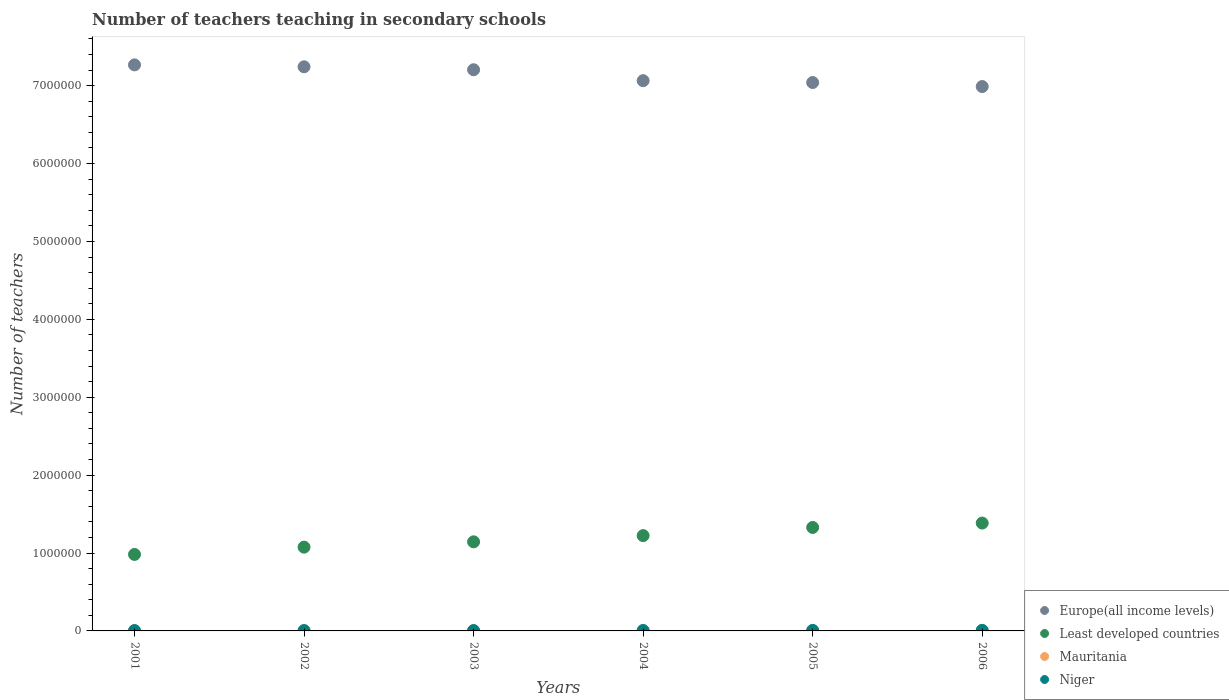Is the number of dotlines equal to the number of legend labels?
Your response must be concise. Yes. What is the number of teachers teaching in secondary schools in Least developed countries in 2001?
Give a very brief answer. 9.82e+05. Across all years, what is the maximum number of teachers teaching in secondary schools in Least developed countries?
Your answer should be compact. 1.38e+06. Across all years, what is the minimum number of teachers teaching in secondary schools in Europe(all income levels)?
Your response must be concise. 6.99e+06. In which year was the number of teachers teaching in secondary schools in Least developed countries minimum?
Offer a very short reply. 2001. What is the total number of teachers teaching in secondary schools in Least developed countries in the graph?
Provide a short and direct response. 7.14e+06. What is the difference between the number of teachers teaching in secondary schools in Niger in 2001 and that in 2006?
Provide a succinct answer. -2769. What is the difference between the number of teachers teaching in secondary schools in Least developed countries in 2006 and the number of teachers teaching in secondary schools in Niger in 2001?
Offer a very short reply. 1.38e+06. What is the average number of teachers teaching in secondary schools in Europe(all income levels) per year?
Your response must be concise. 7.13e+06. In the year 2004, what is the difference between the number of teachers teaching in secondary schools in Europe(all income levels) and number of teachers teaching in secondary schools in Niger?
Make the answer very short. 7.06e+06. What is the ratio of the number of teachers teaching in secondary schools in Least developed countries in 2003 to that in 2004?
Offer a very short reply. 0.93. Is the number of teachers teaching in secondary schools in Niger in 2003 less than that in 2005?
Your response must be concise. Yes. Is the difference between the number of teachers teaching in secondary schools in Europe(all income levels) in 2004 and 2005 greater than the difference between the number of teachers teaching in secondary schools in Niger in 2004 and 2005?
Keep it short and to the point. Yes. What is the difference between the highest and the second highest number of teachers teaching in secondary schools in Niger?
Your answer should be very brief. 725. What is the difference between the highest and the lowest number of teachers teaching in secondary schools in Least developed countries?
Provide a short and direct response. 4.03e+05. Is it the case that in every year, the sum of the number of teachers teaching in secondary schools in Niger and number of teachers teaching in secondary schools in Mauritania  is greater than the sum of number of teachers teaching in secondary schools in Europe(all income levels) and number of teachers teaching in secondary schools in Least developed countries?
Ensure brevity in your answer.  No. Is the number of teachers teaching in secondary schools in Niger strictly greater than the number of teachers teaching in secondary schools in Least developed countries over the years?
Your answer should be compact. No. Is the number of teachers teaching in secondary schools in Europe(all income levels) strictly less than the number of teachers teaching in secondary schools in Mauritania over the years?
Keep it short and to the point. No. How many years are there in the graph?
Your answer should be compact. 6. Are the values on the major ticks of Y-axis written in scientific E-notation?
Keep it short and to the point. No. Does the graph contain grids?
Your answer should be compact. No. Where does the legend appear in the graph?
Keep it short and to the point. Bottom right. How many legend labels are there?
Your answer should be compact. 4. What is the title of the graph?
Offer a very short reply. Number of teachers teaching in secondary schools. Does "West Bank and Gaza" appear as one of the legend labels in the graph?
Your answer should be very brief. No. What is the label or title of the X-axis?
Give a very brief answer. Years. What is the label or title of the Y-axis?
Offer a terse response. Number of teachers. What is the Number of teachers in Europe(all income levels) in 2001?
Keep it short and to the point. 7.27e+06. What is the Number of teachers of Least developed countries in 2001?
Offer a very short reply. 9.82e+05. What is the Number of teachers in Mauritania in 2001?
Ensure brevity in your answer.  2911. What is the Number of teachers of Niger in 2001?
Ensure brevity in your answer.  4589. What is the Number of teachers of Europe(all income levels) in 2002?
Give a very brief answer. 7.24e+06. What is the Number of teachers in Least developed countries in 2002?
Provide a succinct answer. 1.08e+06. What is the Number of teachers in Mauritania in 2002?
Provide a short and direct response. 3000. What is the Number of teachers in Niger in 2002?
Ensure brevity in your answer.  4165. What is the Number of teachers of Europe(all income levels) in 2003?
Keep it short and to the point. 7.20e+06. What is the Number of teachers in Least developed countries in 2003?
Make the answer very short. 1.14e+06. What is the Number of teachers in Mauritania in 2003?
Your answer should be very brief. 3237. What is the Number of teachers of Niger in 2003?
Provide a succinct answer. 4406. What is the Number of teachers of Europe(all income levels) in 2004?
Provide a short and direct response. 7.06e+06. What is the Number of teachers in Least developed countries in 2004?
Your answer should be very brief. 1.22e+06. What is the Number of teachers of Mauritania in 2004?
Your answer should be compact. 3126. What is the Number of teachers in Niger in 2004?
Your response must be concise. 5131. What is the Number of teachers of Europe(all income levels) in 2005?
Your response must be concise. 7.04e+06. What is the Number of teachers of Least developed countries in 2005?
Offer a very short reply. 1.33e+06. What is the Number of teachers of Mauritania in 2005?
Your answer should be compact. 2995. What is the Number of teachers of Niger in 2005?
Keep it short and to the point. 6633. What is the Number of teachers of Europe(all income levels) in 2006?
Provide a short and direct response. 6.99e+06. What is the Number of teachers of Least developed countries in 2006?
Your answer should be compact. 1.38e+06. What is the Number of teachers of Mauritania in 2006?
Your answer should be compact. 3777. What is the Number of teachers in Niger in 2006?
Keep it short and to the point. 7358. Across all years, what is the maximum Number of teachers in Europe(all income levels)?
Your answer should be very brief. 7.27e+06. Across all years, what is the maximum Number of teachers in Least developed countries?
Make the answer very short. 1.38e+06. Across all years, what is the maximum Number of teachers of Mauritania?
Your answer should be very brief. 3777. Across all years, what is the maximum Number of teachers of Niger?
Give a very brief answer. 7358. Across all years, what is the minimum Number of teachers in Europe(all income levels)?
Your answer should be compact. 6.99e+06. Across all years, what is the minimum Number of teachers of Least developed countries?
Give a very brief answer. 9.82e+05. Across all years, what is the minimum Number of teachers of Mauritania?
Offer a terse response. 2911. Across all years, what is the minimum Number of teachers of Niger?
Keep it short and to the point. 4165. What is the total Number of teachers of Europe(all income levels) in the graph?
Provide a succinct answer. 4.28e+07. What is the total Number of teachers in Least developed countries in the graph?
Your answer should be compact. 7.14e+06. What is the total Number of teachers of Mauritania in the graph?
Offer a very short reply. 1.90e+04. What is the total Number of teachers of Niger in the graph?
Give a very brief answer. 3.23e+04. What is the difference between the Number of teachers in Europe(all income levels) in 2001 and that in 2002?
Keep it short and to the point. 2.47e+04. What is the difference between the Number of teachers in Least developed countries in 2001 and that in 2002?
Give a very brief answer. -9.37e+04. What is the difference between the Number of teachers of Mauritania in 2001 and that in 2002?
Give a very brief answer. -89. What is the difference between the Number of teachers of Niger in 2001 and that in 2002?
Offer a terse response. 424. What is the difference between the Number of teachers in Europe(all income levels) in 2001 and that in 2003?
Offer a terse response. 6.26e+04. What is the difference between the Number of teachers of Least developed countries in 2001 and that in 2003?
Keep it short and to the point. -1.62e+05. What is the difference between the Number of teachers in Mauritania in 2001 and that in 2003?
Offer a very short reply. -326. What is the difference between the Number of teachers in Niger in 2001 and that in 2003?
Make the answer very short. 183. What is the difference between the Number of teachers in Europe(all income levels) in 2001 and that in 2004?
Provide a short and direct response. 2.03e+05. What is the difference between the Number of teachers in Least developed countries in 2001 and that in 2004?
Provide a short and direct response. -2.42e+05. What is the difference between the Number of teachers in Mauritania in 2001 and that in 2004?
Provide a short and direct response. -215. What is the difference between the Number of teachers of Niger in 2001 and that in 2004?
Your response must be concise. -542. What is the difference between the Number of teachers in Europe(all income levels) in 2001 and that in 2005?
Provide a succinct answer. 2.27e+05. What is the difference between the Number of teachers of Least developed countries in 2001 and that in 2005?
Provide a short and direct response. -3.47e+05. What is the difference between the Number of teachers in Mauritania in 2001 and that in 2005?
Make the answer very short. -84. What is the difference between the Number of teachers in Niger in 2001 and that in 2005?
Provide a succinct answer. -2044. What is the difference between the Number of teachers in Europe(all income levels) in 2001 and that in 2006?
Your answer should be very brief. 2.78e+05. What is the difference between the Number of teachers in Least developed countries in 2001 and that in 2006?
Keep it short and to the point. -4.03e+05. What is the difference between the Number of teachers of Mauritania in 2001 and that in 2006?
Keep it short and to the point. -866. What is the difference between the Number of teachers of Niger in 2001 and that in 2006?
Provide a succinct answer. -2769. What is the difference between the Number of teachers in Europe(all income levels) in 2002 and that in 2003?
Provide a short and direct response. 3.80e+04. What is the difference between the Number of teachers in Least developed countries in 2002 and that in 2003?
Provide a short and direct response. -6.84e+04. What is the difference between the Number of teachers of Mauritania in 2002 and that in 2003?
Make the answer very short. -237. What is the difference between the Number of teachers of Niger in 2002 and that in 2003?
Give a very brief answer. -241. What is the difference between the Number of teachers in Europe(all income levels) in 2002 and that in 2004?
Make the answer very short. 1.78e+05. What is the difference between the Number of teachers in Least developed countries in 2002 and that in 2004?
Keep it short and to the point. -1.48e+05. What is the difference between the Number of teachers of Mauritania in 2002 and that in 2004?
Your answer should be compact. -126. What is the difference between the Number of teachers in Niger in 2002 and that in 2004?
Offer a very short reply. -966. What is the difference between the Number of teachers in Europe(all income levels) in 2002 and that in 2005?
Offer a terse response. 2.02e+05. What is the difference between the Number of teachers of Least developed countries in 2002 and that in 2005?
Your response must be concise. -2.53e+05. What is the difference between the Number of teachers in Mauritania in 2002 and that in 2005?
Offer a very short reply. 5. What is the difference between the Number of teachers of Niger in 2002 and that in 2005?
Your answer should be compact. -2468. What is the difference between the Number of teachers in Europe(all income levels) in 2002 and that in 2006?
Offer a terse response. 2.54e+05. What is the difference between the Number of teachers of Least developed countries in 2002 and that in 2006?
Your answer should be compact. -3.09e+05. What is the difference between the Number of teachers in Mauritania in 2002 and that in 2006?
Your answer should be very brief. -777. What is the difference between the Number of teachers in Niger in 2002 and that in 2006?
Your answer should be compact. -3193. What is the difference between the Number of teachers in Europe(all income levels) in 2003 and that in 2004?
Your answer should be compact. 1.40e+05. What is the difference between the Number of teachers of Least developed countries in 2003 and that in 2004?
Your answer should be compact. -7.97e+04. What is the difference between the Number of teachers of Mauritania in 2003 and that in 2004?
Provide a succinct answer. 111. What is the difference between the Number of teachers in Niger in 2003 and that in 2004?
Make the answer very short. -725. What is the difference between the Number of teachers of Europe(all income levels) in 2003 and that in 2005?
Make the answer very short. 1.64e+05. What is the difference between the Number of teachers of Least developed countries in 2003 and that in 2005?
Provide a short and direct response. -1.85e+05. What is the difference between the Number of teachers of Mauritania in 2003 and that in 2005?
Your response must be concise. 242. What is the difference between the Number of teachers in Niger in 2003 and that in 2005?
Your response must be concise. -2227. What is the difference between the Number of teachers of Europe(all income levels) in 2003 and that in 2006?
Ensure brevity in your answer.  2.16e+05. What is the difference between the Number of teachers of Least developed countries in 2003 and that in 2006?
Your answer should be compact. -2.41e+05. What is the difference between the Number of teachers of Mauritania in 2003 and that in 2006?
Offer a very short reply. -540. What is the difference between the Number of teachers in Niger in 2003 and that in 2006?
Offer a terse response. -2952. What is the difference between the Number of teachers in Europe(all income levels) in 2004 and that in 2005?
Provide a succinct answer. 2.37e+04. What is the difference between the Number of teachers of Least developed countries in 2004 and that in 2005?
Offer a terse response. -1.05e+05. What is the difference between the Number of teachers in Mauritania in 2004 and that in 2005?
Offer a terse response. 131. What is the difference between the Number of teachers of Niger in 2004 and that in 2005?
Make the answer very short. -1502. What is the difference between the Number of teachers in Europe(all income levels) in 2004 and that in 2006?
Your answer should be very brief. 7.53e+04. What is the difference between the Number of teachers in Least developed countries in 2004 and that in 2006?
Provide a succinct answer. -1.61e+05. What is the difference between the Number of teachers of Mauritania in 2004 and that in 2006?
Give a very brief answer. -651. What is the difference between the Number of teachers of Niger in 2004 and that in 2006?
Ensure brevity in your answer.  -2227. What is the difference between the Number of teachers in Europe(all income levels) in 2005 and that in 2006?
Give a very brief answer. 5.16e+04. What is the difference between the Number of teachers of Least developed countries in 2005 and that in 2006?
Give a very brief answer. -5.61e+04. What is the difference between the Number of teachers in Mauritania in 2005 and that in 2006?
Your response must be concise. -782. What is the difference between the Number of teachers in Niger in 2005 and that in 2006?
Offer a very short reply. -725. What is the difference between the Number of teachers in Europe(all income levels) in 2001 and the Number of teachers in Least developed countries in 2002?
Ensure brevity in your answer.  6.19e+06. What is the difference between the Number of teachers of Europe(all income levels) in 2001 and the Number of teachers of Mauritania in 2002?
Give a very brief answer. 7.26e+06. What is the difference between the Number of teachers of Europe(all income levels) in 2001 and the Number of teachers of Niger in 2002?
Your answer should be very brief. 7.26e+06. What is the difference between the Number of teachers of Least developed countries in 2001 and the Number of teachers of Mauritania in 2002?
Your answer should be very brief. 9.79e+05. What is the difference between the Number of teachers in Least developed countries in 2001 and the Number of teachers in Niger in 2002?
Give a very brief answer. 9.78e+05. What is the difference between the Number of teachers in Mauritania in 2001 and the Number of teachers in Niger in 2002?
Make the answer very short. -1254. What is the difference between the Number of teachers in Europe(all income levels) in 2001 and the Number of teachers in Least developed countries in 2003?
Your answer should be compact. 6.12e+06. What is the difference between the Number of teachers in Europe(all income levels) in 2001 and the Number of teachers in Mauritania in 2003?
Ensure brevity in your answer.  7.26e+06. What is the difference between the Number of teachers of Europe(all income levels) in 2001 and the Number of teachers of Niger in 2003?
Provide a succinct answer. 7.26e+06. What is the difference between the Number of teachers in Least developed countries in 2001 and the Number of teachers in Mauritania in 2003?
Your answer should be very brief. 9.79e+05. What is the difference between the Number of teachers in Least developed countries in 2001 and the Number of teachers in Niger in 2003?
Offer a terse response. 9.77e+05. What is the difference between the Number of teachers in Mauritania in 2001 and the Number of teachers in Niger in 2003?
Offer a terse response. -1495. What is the difference between the Number of teachers in Europe(all income levels) in 2001 and the Number of teachers in Least developed countries in 2004?
Your answer should be very brief. 6.04e+06. What is the difference between the Number of teachers in Europe(all income levels) in 2001 and the Number of teachers in Mauritania in 2004?
Provide a succinct answer. 7.26e+06. What is the difference between the Number of teachers of Europe(all income levels) in 2001 and the Number of teachers of Niger in 2004?
Your answer should be compact. 7.26e+06. What is the difference between the Number of teachers in Least developed countries in 2001 and the Number of teachers in Mauritania in 2004?
Your response must be concise. 9.79e+05. What is the difference between the Number of teachers of Least developed countries in 2001 and the Number of teachers of Niger in 2004?
Give a very brief answer. 9.77e+05. What is the difference between the Number of teachers in Mauritania in 2001 and the Number of teachers in Niger in 2004?
Provide a succinct answer. -2220. What is the difference between the Number of teachers in Europe(all income levels) in 2001 and the Number of teachers in Least developed countries in 2005?
Provide a succinct answer. 5.94e+06. What is the difference between the Number of teachers of Europe(all income levels) in 2001 and the Number of teachers of Mauritania in 2005?
Make the answer very short. 7.26e+06. What is the difference between the Number of teachers of Europe(all income levels) in 2001 and the Number of teachers of Niger in 2005?
Your answer should be very brief. 7.26e+06. What is the difference between the Number of teachers in Least developed countries in 2001 and the Number of teachers in Mauritania in 2005?
Provide a short and direct response. 9.79e+05. What is the difference between the Number of teachers in Least developed countries in 2001 and the Number of teachers in Niger in 2005?
Make the answer very short. 9.75e+05. What is the difference between the Number of teachers of Mauritania in 2001 and the Number of teachers of Niger in 2005?
Provide a succinct answer. -3722. What is the difference between the Number of teachers in Europe(all income levels) in 2001 and the Number of teachers in Least developed countries in 2006?
Your answer should be very brief. 5.88e+06. What is the difference between the Number of teachers of Europe(all income levels) in 2001 and the Number of teachers of Mauritania in 2006?
Keep it short and to the point. 7.26e+06. What is the difference between the Number of teachers in Europe(all income levels) in 2001 and the Number of teachers in Niger in 2006?
Ensure brevity in your answer.  7.26e+06. What is the difference between the Number of teachers in Least developed countries in 2001 and the Number of teachers in Mauritania in 2006?
Your response must be concise. 9.78e+05. What is the difference between the Number of teachers in Least developed countries in 2001 and the Number of teachers in Niger in 2006?
Your answer should be very brief. 9.74e+05. What is the difference between the Number of teachers in Mauritania in 2001 and the Number of teachers in Niger in 2006?
Your response must be concise. -4447. What is the difference between the Number of teachers of Europe(all income levels) in 2002 and the Number of teachers of Least developed countries in 2003?
Offer a terse response. 6.10e+06. What is the difference between the Number of teachers in Europe(all income levels) in 2002 and the Number of teachers in Mauritania in 2003?
Keep it short and to the point. 7.24e+06. What is the difference between the Number of teachers of Europe(all income levels) in 2002 and the Number of teachers of Niger in 2003?
Ensure brevity in your answer.  7.24e+06. What is the difference between the Number of teachers of Least developed countries in 2002 and the Number of teachers of Mauritania in 2003?
Your answer should be very brief. 1.07e+06. What is the difference between the Number of teachers of Least developed countries in 2002 and the Number of teachers of Niger in 2003?
Give a very brief answer. 1.07e+06. What is the difference between the Number of teachers of Mauritania in 2002 and the Number of teachers of Niger in 2003?
Make the answer very short. -1406. What is the difference between the Number of teachers in Europe(all income levels) in 2002 and the Number of teachers in Least developed countries in 2004?
Offer a very short reply. 6.02e+06. What is the difference between the Number of teachers in Europe(all income levels) in 2002 and the Number of teachers in Mauritania in 2004?
Your answer should be very brief. 7.24e+06. What is the difference between the Number of teachers of Europe(all income levels) in 2002 and the Number of teachers of Niger in 2004?
Make the answer very short. 7.24e+06. What is the difference between the Number of teachers of Least developed countries in 2002 and the Number of teachers of Mauritania in 2004?
Make the answer very short. 1.07e+06. What is the difference between the Number of teachers of Least developed countries in 2002 and the Number of teachers of Niger in 2004?
Your answer should be compact. 1.07e+06. What is the difference between the Number of teachers in Mauritania in 2002 and the Number of teachers in Niger in 2004?
Your response must be concise. -2131. What is the difference between the Number of teachers in Europe(all income levels) in 2002 and the Number of teachers in Least developed countries in 2005?
Your answer should be very brief. 5.91e+06. What is the difference between the Number of teachers of Europe(all income levels) in 2002 and the Number of teachers of Mauritania in 2005?
Offer a very short reply. 7.24e+06. What is the difference between the Number of teachers in Europe(all income levels) in 2002 and the Number of teachers in Niger in 2005?
Provide a succinct answer. 7.24e+06. What is the difference between the Number of teachers in Least developed countries in 2002 and the Number of teachers in Mauritania in 2005?
Your answer should be very brief. 1.07e+06. What is the difference between the Number of teachers of Least developed countries in 2002 and the Number of teachers of Niger in 2005?
Your answer should be very brief. 1.07e+06. What is the difference between the Number of teachers of Mauritania in 2002 and the Number of teachers of Niger in 2005?
Give a very brief answer. -3633. What is the difference between the Number of teachers in Europe(all income levels) in 2002 and the Number of teachers in Least developed countries in 2006?
Ensure brevity in your answer.  5.86e+06. What is the difference between the Number of teachers of Europe(all income levels) in 2002 and the Number of teachers of Mauritania in 2006?
Give a very brief answer. 7.24e+06. What is the difference between the Number of teachers in Europe(all income levels) in 2002 and the Number of teachers in Niger in 2006?
Your response must be concise. 7.24e+06. What is the difference between the Number of teachers in Least developed countries in 2002 and the Number of teachers in Mauritania in 2006?
Ensure brevity in your answer.  1.07e+06. What is the difference between the Number of teachers in Least developed countries in 2002 and the Number of teachers in Niger in 2006?
Offer a very short reply. 1.07e+06. What is the difference between the Number of teachers of Mauritania in 2002 and the Number of teachers of Niger in 2006?
Your answer should be very brief. -4358. What is the difference between the Number of teachers in Europe(all income levels) in 2003 and the Number of teachers in Least developed countries in 2004?
Offer a very short reply. 5.98e+06. What is the difference between the Number of teachers of Europe(all income levels) in 2003 and the Number of teachers of Mauritania in 2004?
Provide a succinct answer. 7.20e+06. What is the difference between the Number of teachers in Europe(all income levels) in 2003 and the Number of teachers in Niger in 2004?
Ensure brevity in your answer.  7.20e+06. What is the difference between the Number of teachers in Least developed countries in 2003 and the Number of teachers in Mauritania in 2004?
Provide a short and direct response. 1.14e+06. What is the difference between the Number of teachers of Least developed countries in 2003 and the Number of teachers of Niger in 2004?
Keep it short and to the point. 1.14e+06. What is the difference between the Number of teachers of Mauritania in 2003 and the Number of teachers of Niger in 2004?
Keep it short and to the point. -1894. What is the difference between the Number of teachers in Europe(all income levels) in 2003 and the Number of teachers in Least developed countries in 2005?
Your response must be concise. 5.88e+06. What is the difference between the Number of teachers of Europe(all income levels) in 2003 and the Number of teachers of Mauritania in 2005?
Make the answer very short. 7.20e+06. What is the difference between the Number of teachers in Europe(all income levels) in 2003 and the Number of teachers in Niger in 2005?
Provide a succinct answer. 7.20e+06. What is the difference between the Number of teachers of Least developed countries in 2003 and the Number of teachers of Mauritania in 2005?
Offer a terse response. 1.14e+06. What is the difference between the Number of teachers of Least developed countries in 2003 and the Number of teachers of Niger in 2005?
Your answer should be compact. 1.14e+06. What is the difference between the Number of teachers in Mauritania in 2003 and the Number of teachers in Niger in 2005?
Give a very brief answer. -3396. What is the difference between the Number of teachers of Europe(all income levels) in 2003 and the Number of teachers of Least developed countries in 2006?
Make the answer very short. 5.82e+06. What is the difference between the Number of teachers of Europe(all income levels) in 2003 and the Number of teachers of Mauritania in 2006?
Your answer should be compact. 7.20e+06. What is the difference between the Number of teachers in Europe(all income levels) in 2003 and the Number of teachers in Niger in 2006?
Ensure brevity in your answer.  7.20e+06. What is the difference between the Number of teachers of Least developed countries in 2003 and the Number of teachers of Mauritania in 2006?
Your response must be concise. 1.14e+06. What is the difference between the Number of teachers of Least developed countries in 2003 and the Number of teachers of Niger in 2006?
Make the answer very short. 1.14e+06. What is the difference between the Number of teachers of Mauritania in 2003 and the Number of teachers of Niger in 2006?
Provide a short and direct response. -4121. What is the difference between the Number of teachers in Europe(all income levels) in 2004 and the Number of teachers in Least developed countries in 2005?
Offer a very short reply. 5.74e+06. What is the difference between the Number of teachers in Europe(all income levels) in 2004 and the Number of teachers in Mauritania in 2005?
Offer a terse response. 7.06e+06. What is the difference between the Number of teachers in Europe(all income levels) in 2004 and the Number of teachers in Niger in 2005?
Provide a succinct answer. 7.06e+06. What is the difference between the Number of teachers in Least developed countries in 2004 and the Number of teachers in Mauritania in 2005?
Make the answer very short. 1.22e+06. What is the difference between the Number of teachers of Least developed countries in 2004 and the Number of teachers of Niger in 2005?
Give a very brief answer. 1.22e+06. What is the difference between the Number of teachers of Mauritania in 2004 and the Number of teachers of Niger in 2005?
Offer a terse response. -3507. What is the difference between the Number of teachers in Europe(all income levels) in 2004 and the Number of teachers in Least developed countries in 2006?
Your answer should be very brief. 5.68e+06. What is the difference between the Number of teachers of Europe(all income levels) in 2004 and the Number of teachers of Mauritania in 2006?
Ensure brevity in your answer.  7.06e+06. What is the difference between the Number of teachers of Europe(all income levels) in 2004 and the Number of teachers of Niger in 2006?
Your response must be concise. 7.06e+06. What is the difference between the Number of teachers of Least developed countries in 2004 and the Number of teachers of Mauritania in 2006?
Offer a terse response. 1.22e+06. What is the difference between the Number of teachers in Least developed countries in 2004 and the Number of teachers in Niger in 2006?
Your answer should be compact. 1.22e+06. What is the difference between the Number of teachers of Mauritania in 2004 and the Number of teachers of Niger in 2006?
Keep it short and to the point. -4232. What is the difference between the Number of teachers of Europe(all income levels) in 2005 and the Number of teachers of Least developed countries in 2006?
Keep it short and to the point. 5.66e+06. What is the difference between the Number of teachers in Europe(all income levels) in 2005 and the Number of teachers in Mauritania in 2006?
Ensure brevity in your answer.  7.04e+06. What is the difference between the Number of teachers of Europe(all income levels) in 2005 and the Number of teachers of Niger in 2006?
Offer a very short reply. 7.03e+06. What is the difference between the Number of teachers of Least developed countries in 2005 and the Number of teachers of Mauritania in 2006?
Offer a terse response. 1.32e+06. What is the difference between the Number of teachers in Least developed countries in 2005 and the Number of teachers in Niger in 2006?
Make the answer very short. 1.32e+06. What is the difference between the Number of teachers in Mauritania in 2005 and the Number of teachers in Niger in 2006?
Keep it short and to the point. -4363. What is the average Number of teachers of Europe(all income levels) per year?
Ensure brevity in your answer.  7.13e+06. What is the average Number of teachers in Least developed countries per year?
Your response must be concise. 1.19e+06. What is the average Number of teachers of Mauritania per year?
Offer a terse response. 3174.33. What is the average Number of teachers in Niger per year?
Your response must be concise. 5380.33. In the year 2001, what is the difference between the Number of teachers in Europe(all income levels) and Number of teachers in Least developed countries?
Your response must be concise. 6.29e+06. In the year 2001, what is the difference between the Number of teachers of Europe(all income levels) and Number of teachers of Mauritania?
Ensure brevity in your answer.  7.26e+06. In the year 2001, what is the difference between the Number of teachers in Europe(all income levels) and Number of teachers in Niger?
Your answer should be compact. 7.26e+06. In the year 2001, what is the difference between the Number of teachers in Least developed countries and Number of teachers in Mauritania?
Your answer should be compact. 9.79e+05. In the year 2001, what is the difference between the Number of teachers in Least developed countries and Number of teachers in Niger?
Your response must be concise. 9.77e+05. In the year 2001, what is the difference between the Number of teachers in Mauritania and Number of teachers in Niger?
Your answer should be very brief. -1678. In the year 2002, what is the difference between the Number of teachers in Europe(all income levels) and Number of teachers in Least developed countries?
Keep it short and to the point. 6.17e+06. In the year 2002, what is the difference between the Number of teachers of Europe(all income levels) and Number of teachers of Mauritania?
Your answer should be very brief. 7.24e+06. In the year 2002, what is the difference between the Number of teachers in Europe(all income levels) and Number of teachers in Niger?
Your response must be concise. 7.24e+06. In the year 2002, what is the difference between the Number of teachers of Least developed countries and Number of teachers of Mauritania?
Ensure brevity in your answer.  1.07e+06. In the year 2002, what is the difference between the Number of teachers of Least developed countries and Number of teachers of Niger?
Your response must be concise. 1.07e+06. In the year 2002, what is the difference between the Number of teachers of Mauritania and Number of teachers of Niger?
Offer a very short reply. -1165. In the year 2003, what is the difference between the Number of teachers in Europe(all income levels) and Number of teachers in Least developed countries?
Your response must be concise. 6.06e+06. In the year 2003, what is the difference between the Number of teachers of Europe(all income levels) and Number of teachers of Mauritania?
Offer a terse response. 7.20e+06. In the year 2003, what is the difference between the Number of teachers in Europe(all income levels) and Number of teachers in Niger?
Provide a short and direct response. 7.20e+06. In the year 2003, what is the difference between the Number of teachers of Least developed countries and Number of teachers of Mauritania?
Your answer should be compact. 1.14e+06. In the year 2003, what is the difference between the Number of teachers in Least developed countries and Number of teachers in Niger?
Make the answer very short. 1.14e+06. In the year 2003, what is the difference between the Number of teachers in Mauritania and Number of teachers in Niger?
Your answer should be very brief. -1169. In the year 2004, what is the difference between the Number of teachers in Europe(all income levels) and Number of teachers in Least developed countries?
Give a very brief answer. 5.84e+06. In the year 2004, what is the difference between the Number of teachers in Europe(all income levels) and Number of teachers in Mauritania?
Offer a very short reply. 7.06e+06. In the year 2004, what is the difference between the Number of teachers in Europe(all income levels) and Number of teachers in Niger?
Ensure brevity in your answer.  7.06e+06. In the year 2004, what is the difference between the Number of teachers in Least developed countries and Number of teachers in Mauritania?
Keep it short and to the point. 1.22e+06. In the year 2004, what is the difference between the Number of teachers in Least developed countries and Number of teachers in Niger?
Provide a short and direct response. 1.22e+06. In the year 2004, what is the difference between the Number of teachers in Mauritania and Number of teachers in Niger?
Offer a terse response. -2005. In the year 2005, what is the difference between the Number of teachers of Europe(all income levels) and Number of teachers of Least developed countries?
Your response must be concise. 5.71e+06. In the year 2005, what is the difference between the Number of teachers in Europe(all income levels) and Number of teachers in Mauritania?
Provide a succinct answer. 7.04e+06. In the year 2005, what is the difference between the Number of teachers in Europe(all income levels) and Number of teachers in Niger?
Give a very brief answer. 7.03e+06. In the year 2005, what is the difference between the Number of teachers in Least developed countries and Number of teachers in Mauritania?
Provide a succinct answer. 1.33e+06. In the year 2005, what is the difference between the Number of teachers of Least developed countries and Number of teachers of Niger?
Offer a terse response. 1.32e+06. In the year 2005, what is the difference between the Number of teachers in Mauritania and Number of teachers in Niger?
Offer a terse response. -3638. In the year 2006, what is the difference between the Number of teachers of Europe(all income levels) and Number of teachers of Least developed countries?
Ensure brevity in your answer.  5.60e+06. In the year 2006, what is the difference between the Number of teachers of Europe(all income levels) and Number of teachers of Mauritania?
Your answer should be very brief. 6.99e+06. In the year 2006, what is the difference between the Number of teachers of Europe(all income levels) and Number of teachers of Niger?
Your answer should be compact. 6.98e+06. In the year 2006, what is the difference between the Number of teachers of Least developed countries and Number of teachers of Mauritania?
Give a very brief answer. 1.38e+06. In the year 2006, what is the difference between the Number of teachers in Least developed countries and Number of teachers in Niger?
Your answer should be very brief. 1.38e+06. In the year 2006, what is the difference between the Number of teachers of Mauritania and Number of teachers of Niger?
Keep it short and to the point. -3581. What is the ratio of the Number of teachers in Europe(all income levels) in 2001 to that in 2002?
Keep it short and to the point. 1. What is the ratio of the Number of teachers of Least developed countries in 2001 to that in 2002?
Your answer should be compact. 0.91. What is the ratio of the Number of teachers in Mauritania in 2001 to that in 2002?
Make the answer very short. 0.97. What is the ratio of the Number of teachers of Niger in 2001 to that in 2002?
Make the answer very short. 1.1. What is the ratio of the Number of teachers in Europe(all income levels) in 2001 to that in 2003?
Your answer should be compact. 1.01. What is the ratio of the Number of teachers in Least developed countries in 2001 to that in 2003?
Keep it short and to the point. 0.86. What is the ratio of the Number of teachers in Mauritania in 2001 to that in 2003?
Your answer should be very brief. 0.9. What is the ratio of the Number of teachers in Niger in 2001 to that in 2003?
Your answer should be compact. 1.04. What is the ratio of the Number of teachers of Europe(all income levels) in 2001 to that in 2004?
Your answer should be very brief. 1.03. What is the ratio of the Number of teachers in Least developed countries in 2001 to that in 2004?
Provide a succinct answer. 0.8. What is the ratio of the Number of teachers in Mauritania in 2001 to that in 2004?
Your answer should be compact. 0.93. What is the ratio of the Number of teachers in Niger in 2001 to that in 2004?
Your answer should be very brief. 0.89. What is the ratio of the Number of teachers in Europe(all income levels) in 2001 to that in 2005?
Make the answer very short. 1.03. What is the ratio of the Number of teachers of Least developed countries in 2001 to that in 2005?
Offer a terse response. 0.74. What is the ratio of the Number of teachers in Niger in 2001 to that in 2005?
Provide a short and direct response. 0.69. What is the ratio of the Number of teachers in Europe(all income levels) in 2001 to that in 2006?
Provide a succinct answer. 1.04. What is the ratio of the Number of teachers of Least developed countries in 2001 to that in 2006?
Ensure brevity in your answer.  0.71. What is the ratio of the Number of teachers of Mauritania in 2001 to that in 2006?
Ensure brevity in your answer.  0.77. What is the ratio of the Number of teachers of Niger in 2001 to that in 2006?
Keep it short and to the point. 0.62. What is the ratio of the Number of teachers in Europe(all income levels) in 2002 to that in 2003?
Give a very brief answer. 1.01. What is the ratio of the Number of teachers in Least developed countries in 2002 to that in 2003?
Your answer should be compact. 0.94. What is the ratio of the Number of teachers of Mauritania in 2002 to that in 2003?
Provide a short and direct response. 0.93. What is the ratio of the Number of teachers of Niger in 2002 to that in 2003?
Offer a terse response. 0.95. What is the ratio of the Number of teachers in Europe(all income levels) in 2002 to that in 2004?
Provide a short and direct response. 1.03. What is the ratio of the Number of teachers of Least developed countries in 2002 to that in 2004?
Make the answer very short. 0.88. What is the ratio of the Number of teachers in Mauritania in 2002 to that in 2004?
Offer a very short reply. 0.96. What is the ratio of the Number of teachers of Niger in 2002 to that in 2004?
Your response must be concise. 0.81. What is the ratio of the Number of teachers in Europe(all income levels) in 2002 to that in 2005?
Offer a very short reply. 1.03. What is the ratio of the Number of teachers in Least developed countries in 2002 to that in 2005?
Your response must be concise. 0.81. What is the ratio of the Number of teachers of Niger in 2002 to that in 2005?
Give a very brief answer. 0.63. What is the ratio of the Number of teachers of Europe(all income levels) in 2002 to that in 2006?
Make the answer very short. 1.04. What is the ratio of the Number of teachers of Least developed countries in 2002 to that in 2006?
Ensure brevity in your answer.  0.78. What is the ratio of the Number of teachers in Mauritania in 2002 to that in 2006?
Your response must be concise. 0.79. What is the ratio of the Number of teachers of Niger in 2002 to that in 2006?
Your answer should be very brief. 0.57. What is the ratio of the Number of teachers of Europe(all income levels) in 2003 to that in 2004?
Your response must be concise. 1.02. What is the ratio of the Number of teachers in Least developed countries in 2003 to that in 2004?
Provide a succinct answer. 0.93. What is the ratio of the Number of teachers of Mauritania in 2003 to that in 2004?
Your answer should be very brief. 1.04. What is the ratio of the Number of teachers of Niger in 2003 to that in 2004?
Make the answer very short. 0.86. What is the ratio of the Number of teachers in Europe(all income levels) in 2003 to that in 2005?
Your answer should be compact. 1.02. What is the ratio of the Number of teachers of Least developed countries in 2003 to that in 2005?
Keep it short and to the point. 0.86. What is the ratio of the Number of teachers of Mauritania in 2003 to that in 2005?
Make the answer very short. 1.08. What is the ratio of the Number of teachers of Niger in 2003 to that in 2005?
Make the answer very short. 0.66. What is the ratio of the Number of teachers of Europe(all income levels) in 2003 to that in 2006?
Keep it short and to the point. 1.03. What is the ratio of the Number of teachers of Least developed countries in 2003 to that in 2006?
Offer a very short reply. 0.83. What is the ratio of the Number of teachers in Mauritania in 2003 to that in 2006?
Give a very brief answer. 0.86. What is the ratio of the Number of teachers of Niger in 2003 to that in 2006?
Ensure brevity in your answer.  0.6. What is the ratio of the Number of teachers in Least developed countries in 2004 to that in 2005?
Make the answer very short. 0.92. What is the ratio of the Number of teachers of Mauritania in 2004 to that in 2005?
Give a very brief answer. 1.04. What is the ratio of the Number of teachers of Niger in 2004 to that in 2005?
Your answer should be very brief. 0.77. What is the ratio of the Number of teachers of Europe(all income levels) in 2004 to that in 2006?
Your answer should be compact. 1.01. What is the ratio of the Number of teachers in Least developed countries in 2004 to that in 2006?
Give a very brief answer. 0.88. What is the ratio of the Number of teachers in Mauritania in 2004 to that in 2006?
Give a very brief answer. 0.83. What is the ratio of the Number of teachers of Niger in 2004 to that in 2006?
Your answer should be compact. 0.7. What is the ratio of the Number of teachers in Europe(all income levels) in 2005 to that in 2006?
Your response must be concise. 1.01. What is the ratio of the Number of teachers in Least developed countries in 2005 to that in 2006?
Keep it short and to the point. 0.96. What is the ratio of the Number of teachers of Mauritania in 2005 to that in 2006?
Your answer should be very brief. 0.79. What is the ratio of the Number of teachers in Niger in 2005 to that in 2006?
Keep it short and to the point. 0.9. What is the difference between the highest and the second highest Number of teachers of Europe(all income levels)?
Provide a succinct answer. 2.47e+04. What is the difference between the highest and the second highest Number of teachers in Least developed countries?
Ensure brevity in your answer.  5.61e+04. What is the difference between the highest and the second highest Number of teachers in Mauritania?
Provide a short and direct response. 540. What is the difference between the highest and the second highest Number of teachers in Niger?
Provide a succinct answer. 725. What is the difference between the highest and the lowest Number of teachers in Europe(all income levels)?
Keep it short and to the point. 2.78e+05. What is the difference between the highest and the lowest Number of teachers of Least developed countries?
Your answer should be very brief. 4.03e+05. What is the difference between the highest and the lowest Number of teachers of Mauritania?
Your answer should be very brief. 866. What is the difference between the highest and the lowest Number of teachers in Niger?
Make the answer very short. 3193. 